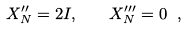<formula> <loc_0><loc_0><loc_500><loc_500>X ^ { \prime \prime } _ { N } = 2 I , \quad X ^ { \prime \prime \prime } _ { N } = 0 \ ,</formula> 